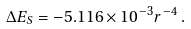<formula> <loc_0><loc_0><loc_500><loc_500>\Delta E _ { S } = - 5 . 1 1 6 \times 1 0 ^ { - 3 } r ^ { - 4 } \, .</formula> 